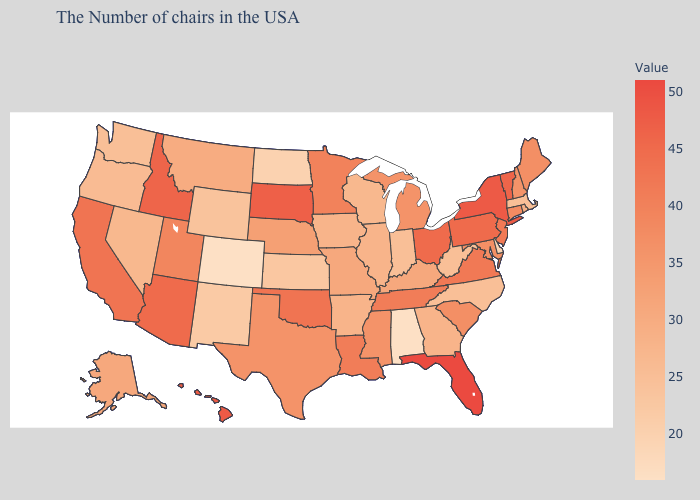Which states have the lowest value in the MidWest?
Write a very short answer. North Dakota. Which states have the lowest value in the South?
Give a very brief answer. Alabama. Does Colorado have the lowest value in the USA?
Give a very brief answer. Yes. 